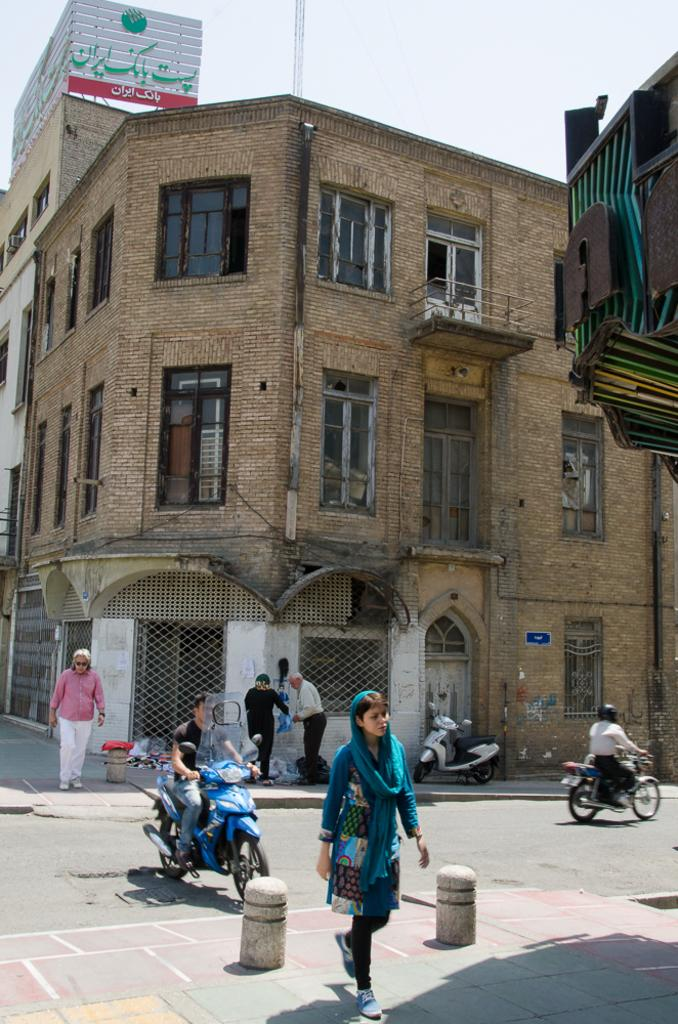What is the main structure visible in the image? There is a huge building in the image. What can be seen on the road in front of the building? There are people standing on the road in the image, and a person is riding a scooter on the road. What type of shoes is the person riding the scooter wearing in the image? There is no information about the shoes the person is wearing in the image. 